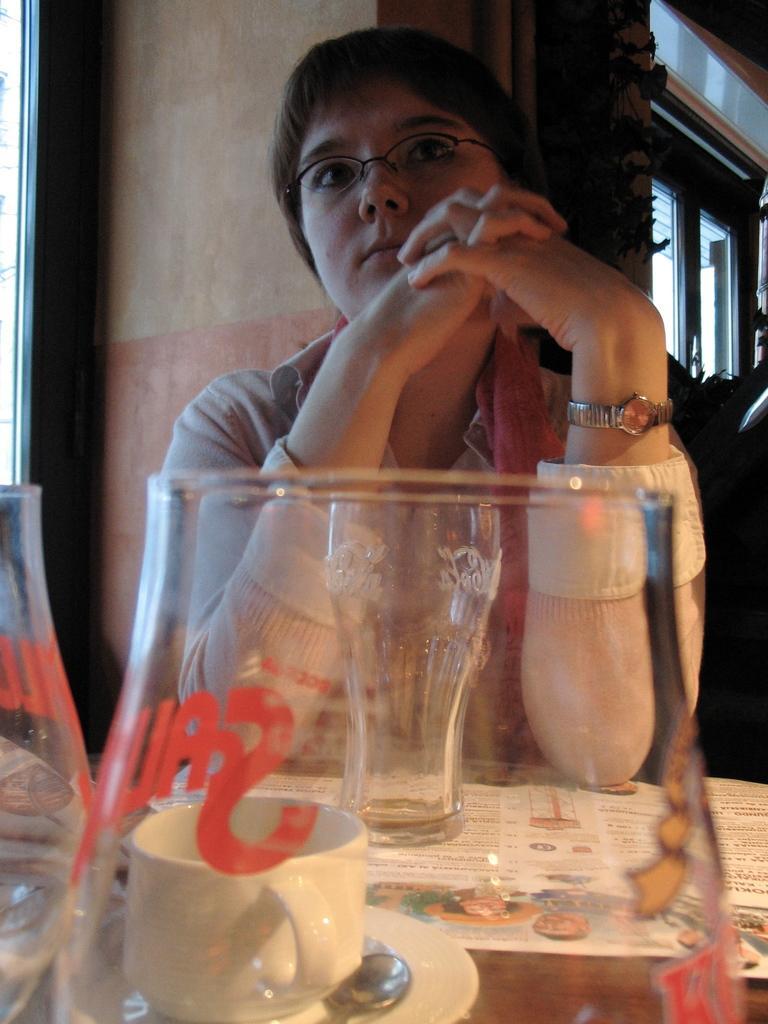Please provide a concise description of this image. In this image I can see a person wearing pink and white colored dress is sitting in front of a table and on the table I can see a paper, few glasses, a cup, a saucer and a spoon. In the background I can see the wall, a plant, few windows and few other objects. 